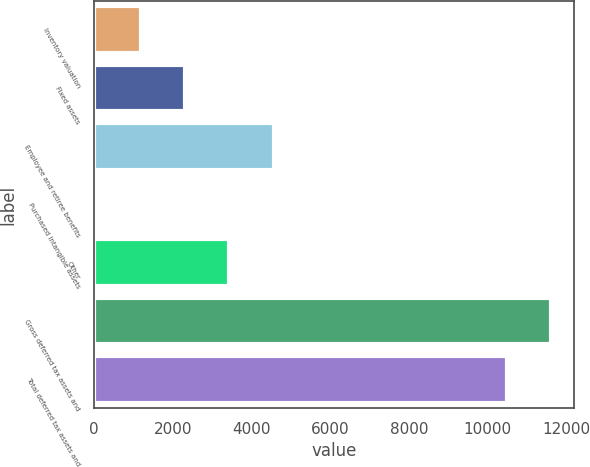Convert chart. <chart><loc_0><loc_0><loc_500><loc_500><bar_chart><fcel>Inventory valuation<fcel>Fixed assets<fcel>Employee and retiree benefits<fcel>Purchased intangible assets<fcel>Other<fcel>Gross deferred tax assets and<fcel>Total deferred tax assets and<nl><fcel>1184.3<fcel>2310.6<fcel>4563.2<fcel>58<fcel>3436.9<fcel>11607.3<fcel>10481<nl></chart> 